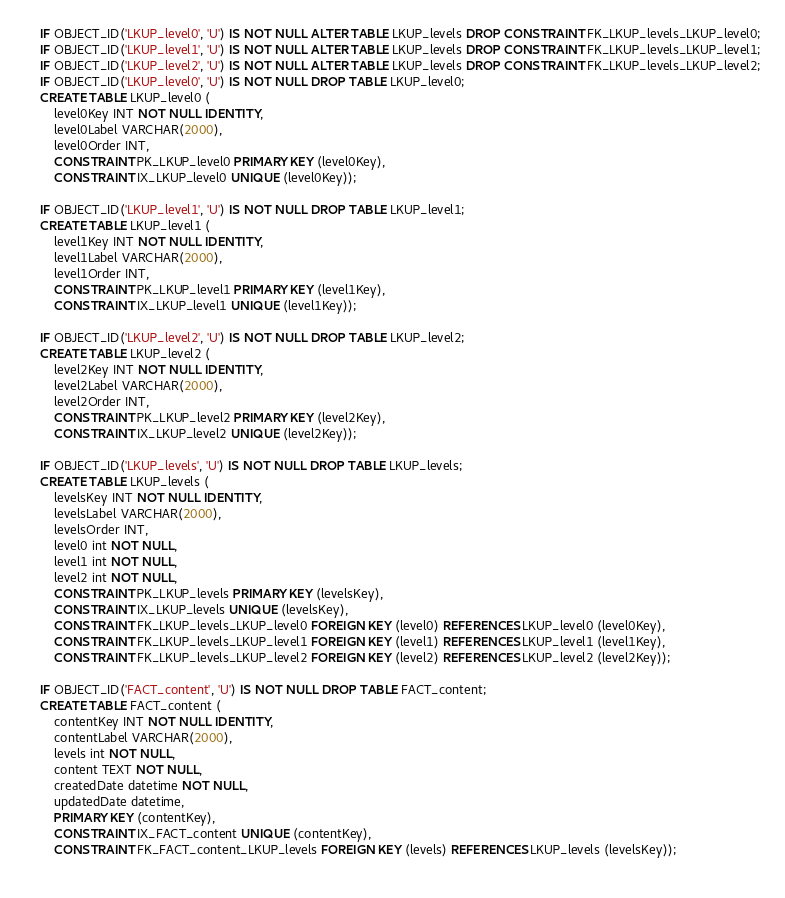<code> <loc_0><loc_0><loc_500><loc_500><_SQL_>IF OBJECT_ID('LKUP_level0', 'U') IS NOT NULL ALTER TABLE LKUP_levels DROP CONSTRAINT FK_LKUP_levels_LKUP_level0;
IF OBJECT_ID('LKUP_level1', 'U') IS NOT NULL ALTER TABLE LKUP_levels DROP CONSTRAINT FK_LKUP_levels_LKUP_level1;
IF OBJECT_ID('LKUP_level2', 'U') IS NOT NULL ALTER TABLE LKUP_levels DROP CONSTRAINT FK_LKUP_levels_LKUP_level2;
IF OBJECT_ID('LKUP_level0', 'U') IS NOT NULL DROP TABLE LKUP_level0;
CREATE TABLE LKUP_level0 (
	level0Key INT NOT NULL IDENTITY,
	level0Label VARCHAR(2000),
	level0Order INT,
	CONSTRAINT PK_LKUP_level0 PRIMARY KEY (level0Key),
	CONSTRAINT IX_LKUP_level0 UNIQUE (level0Key));

IF OBJECT_ID('LKUP_level1', 'U') IS NOT NULL DROP TABLE LKUP_level1;
CREATE TABLE LKUP_level1 (
	level1Key INT NOT NULL IDENTITY,
	level1Label VARCHAR(2000),
	level1Order INT,
	CONSTRAINT PK_LKUP_level1 PRIMARY KEY (level1Key),
	CONSTRAINT IX_LKUP_level1 UNIQUE (level1Key));

IF OBJECT_ID('LKUP_level2', 'U') IS NOT NULL DROP TABLE LKUP_level2;
CREATE TABLE LKUP_level2 (
	level2Key INT NOT NULL IDENTITY,
	level2Label VARCHAR(2000),
	level2Order INT,
	CONSTRAINT PK_LKUP_level2 PRIMARY KEY (level2Key),
	CONSTRAINT IX_LKUP_level2 UNIQUE (level2Key));
	
IF OBJECT_ID('LKUP_levels', 'U') IS NOT NULL DROP TABLE LKUP_levels;
CREATE TABLE LKUP_levels (
	levelsKey INT NOT NULL IDENTITY,
	levelsLabel VARCHAR(2000),
	levelsOrder INT,
	level0 int NOT NULL,
	level1 int NOT NULL,
	level2 int NOT NULL,
	CONSTRAINT PK_LKUP_levels PRIMARY KEY (levelsKey),
	CONSTRAINT IX_LKUP_levels UNIQUE (levelsKey),
	CONSTRAINT FK_LKUP_levels_LKUP_level0 FOREIGN KEY (level0) REFERENCES LKUP_level0 (level0Key),
	CONSTRAINT FK_LKUP_levels_LKUP_level1 FOREIGN KEY (level1) REFERENCES LKUP_level1 (level1Key),
	CONSTRAINT FK_LKUP_levels_LKUP_level2 FOREIGN KEY (level2) REFERENCES LKUP_level2 (level2Key));

IF OBJECT_ID('FACT_content', 'U') IS NOT NULL DROP TABLE FACT_content;
CREATE TABLE FACT_content (
	contentKey INT NOT NULL IDENTITY,
	contentLabel VARCHAR(2000),
	levels int NOT NULL,
	content TEXT NOT NULL,
	createdDate datetime NOT NULL,
	updatedDate datetime,
	PRIMARY KEY (contentKey),
	CONSTRAINT IX_FACT_content UNIQUE (contentKey),
	CONSTRAINT FK_FACT_content_LKUP_levels FOREIGN KEY (levels) REFERENCES LKUP_levels (levelsKey));
	
</code> 